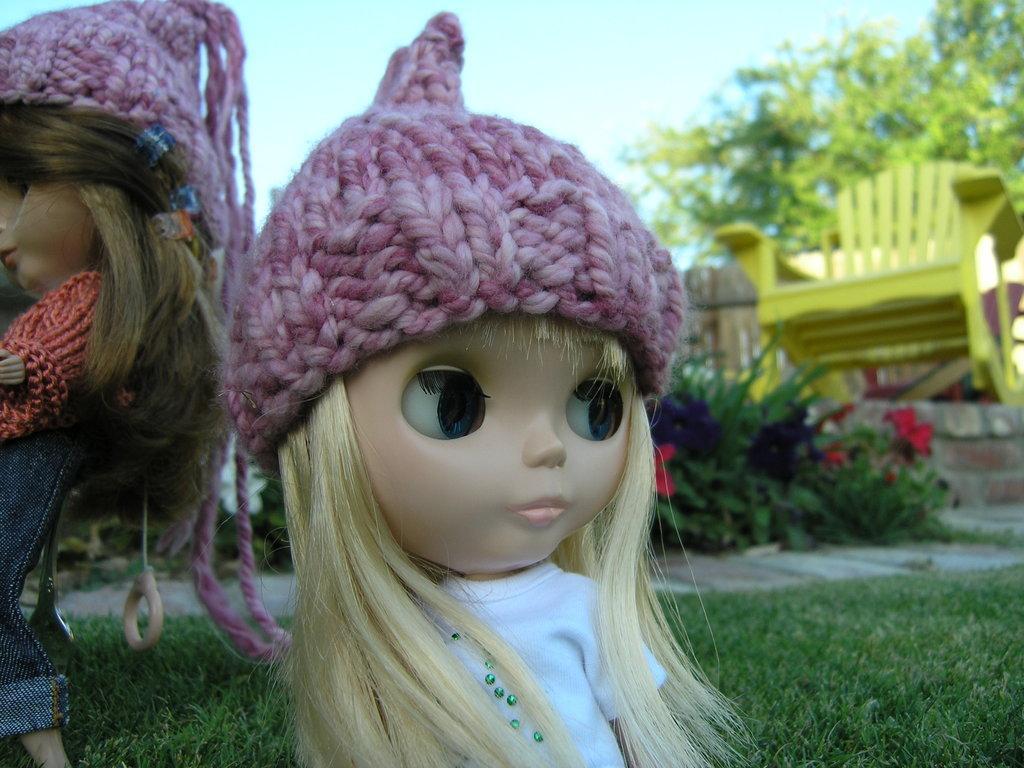Please provide a concise description of this image. In this image I can see few dolls and I can see pink colour caps on their head. In the background I can see grass, few plants, a yellow colour chair, a tree and the sky. 